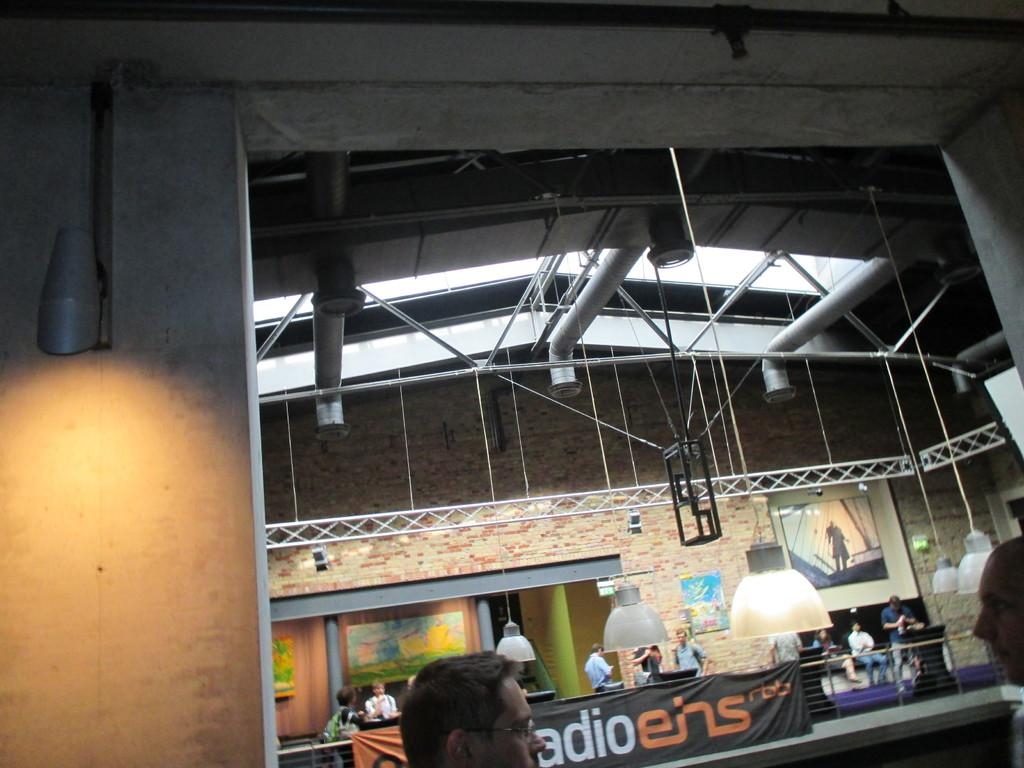What is happening in the image? There is a group of people standing in the image. What can be seen in the background of the image? There is a group of poles, a banner with some text, lights, and a photo frame on the wall in the background of the image. What type of surprise is hidden in the photo frame in the image? There is no mention of a surprise hidden in the photo frame in the image. The photo frame is simply present on the wall in the background. 